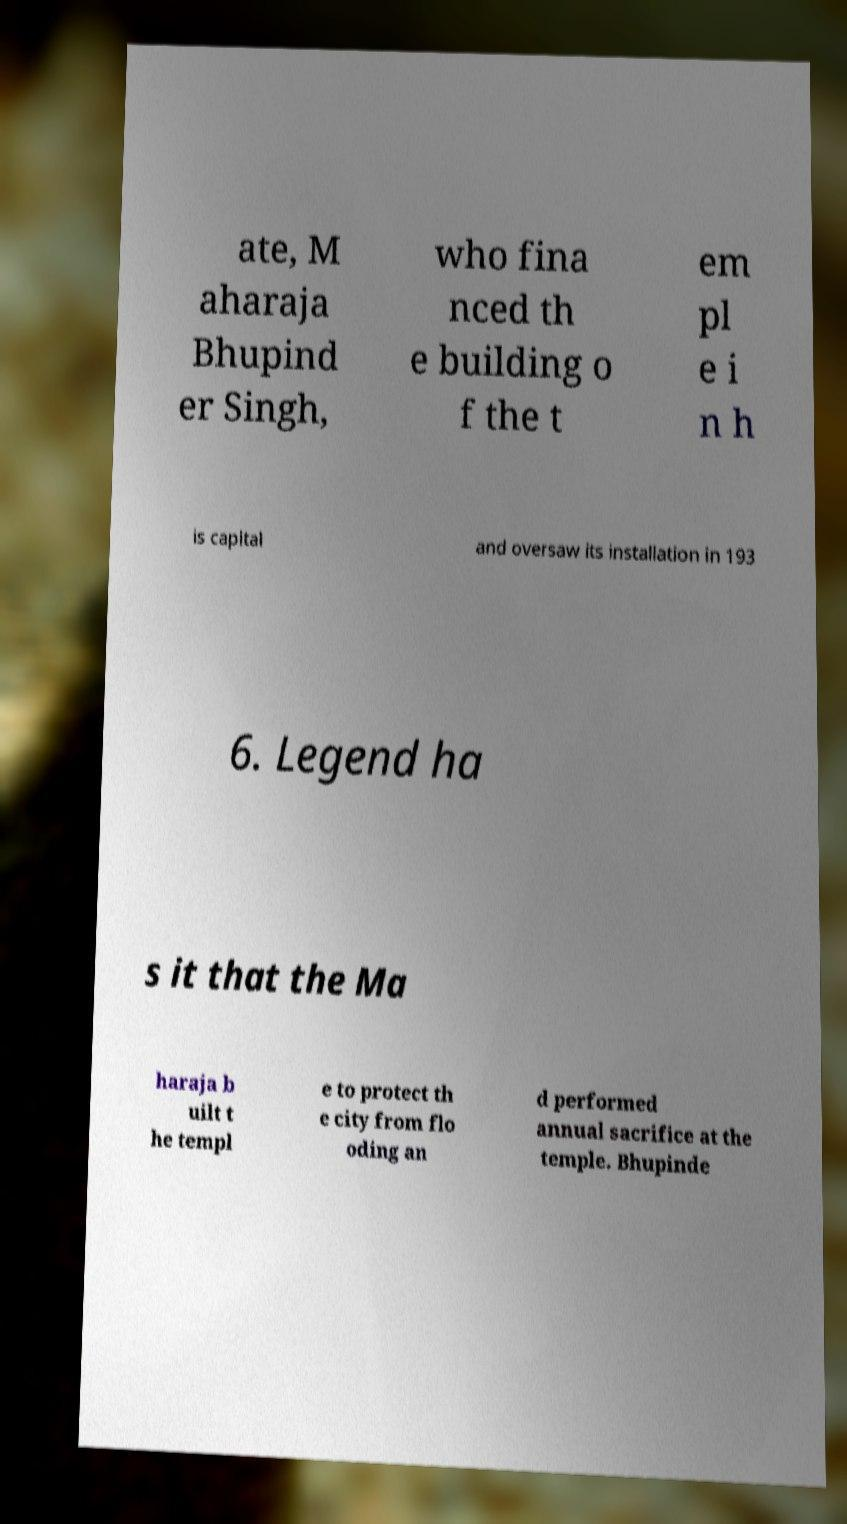Can you accurately transcribe the text from the provided image for me? ate, M aharaja Bhupind er Singh, who fina nced th e building o f the t em pl e i n h is capital and oversaw its installation in 193 6. Legend ha s it that the Ma haraja b uilt t he templ e to protect th e city from flo oding an d performed annual sacrifice at the temple. Bhupinde 